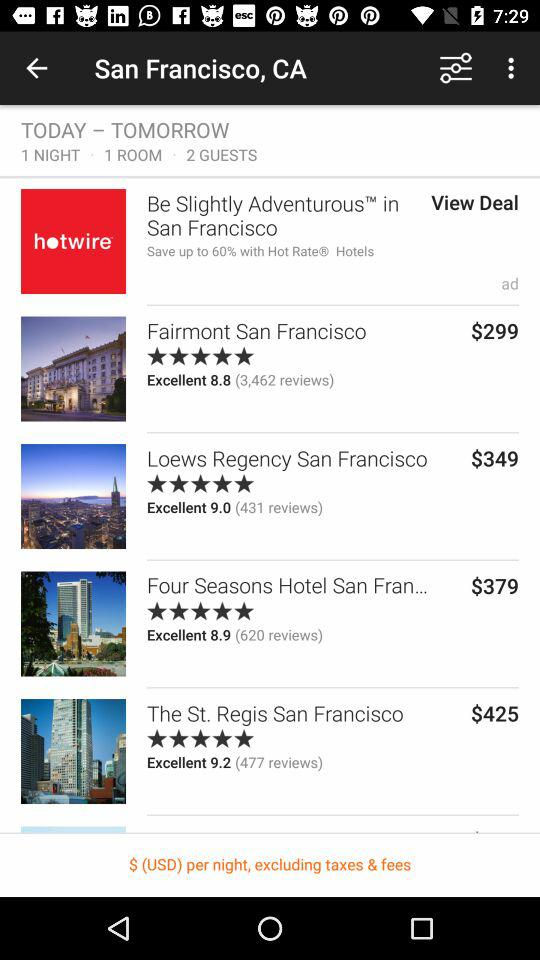What is the rating of "Fairmont San Francisco" hotel? The rating is Excellent (8.8). 